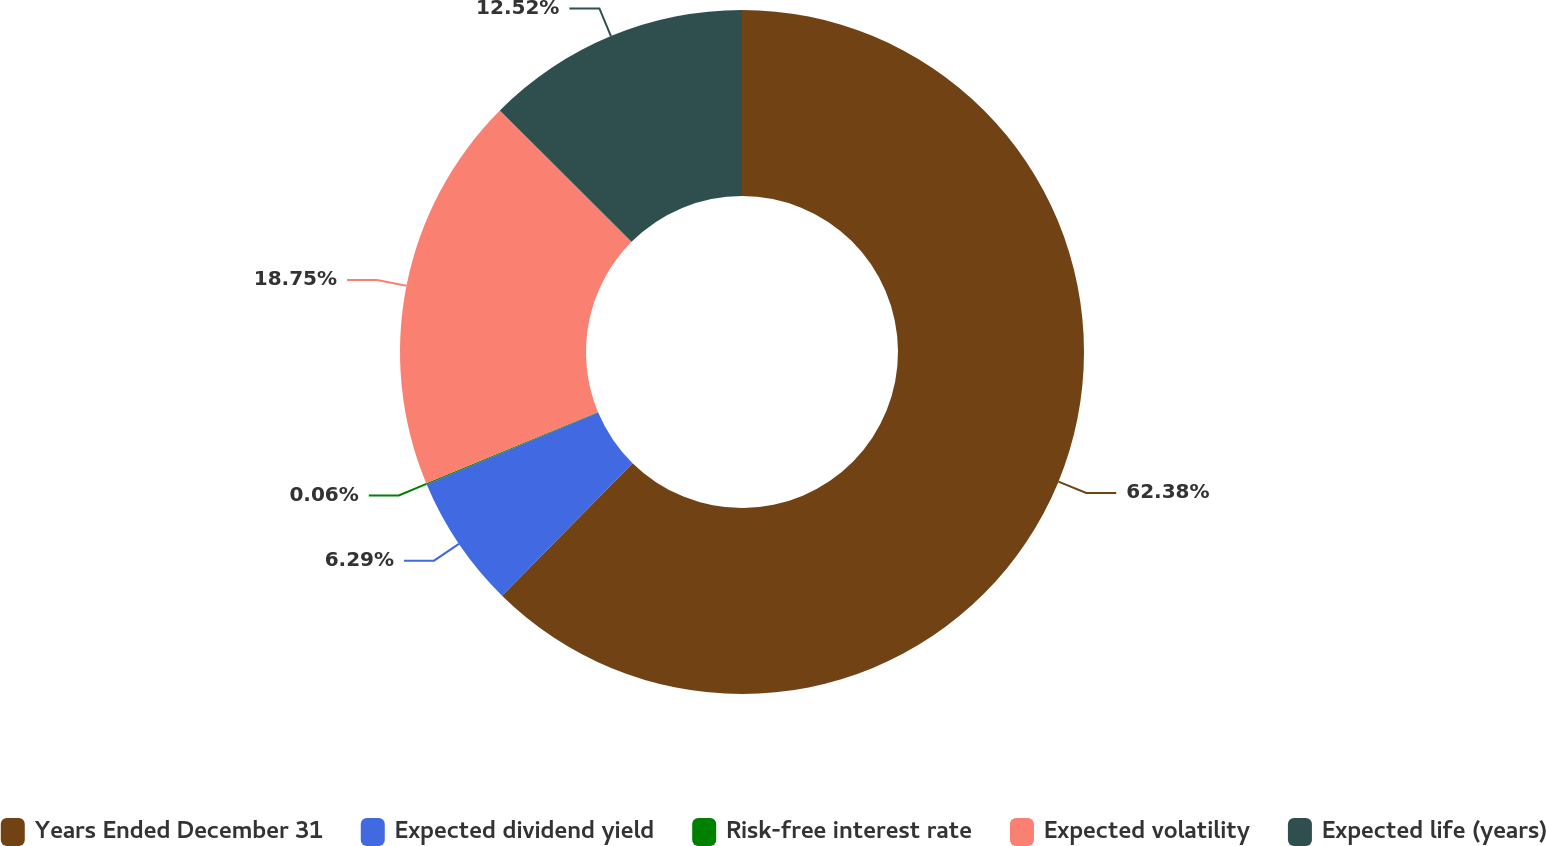Convert chart. <chart><loc_0><loc_0><loc_500><loc_500><pie_chart><fcel>Years Ended December 31<fcel>Expected dividend yield<fcel>Risk-free interest rate<fcel>Expected volatility<fcel>Expected life (years)<nl><fcel>62.37%<fcel>6.29%<fcel>0.06%<fcel>18.75%<fcel>12.52%<nl></chart> 